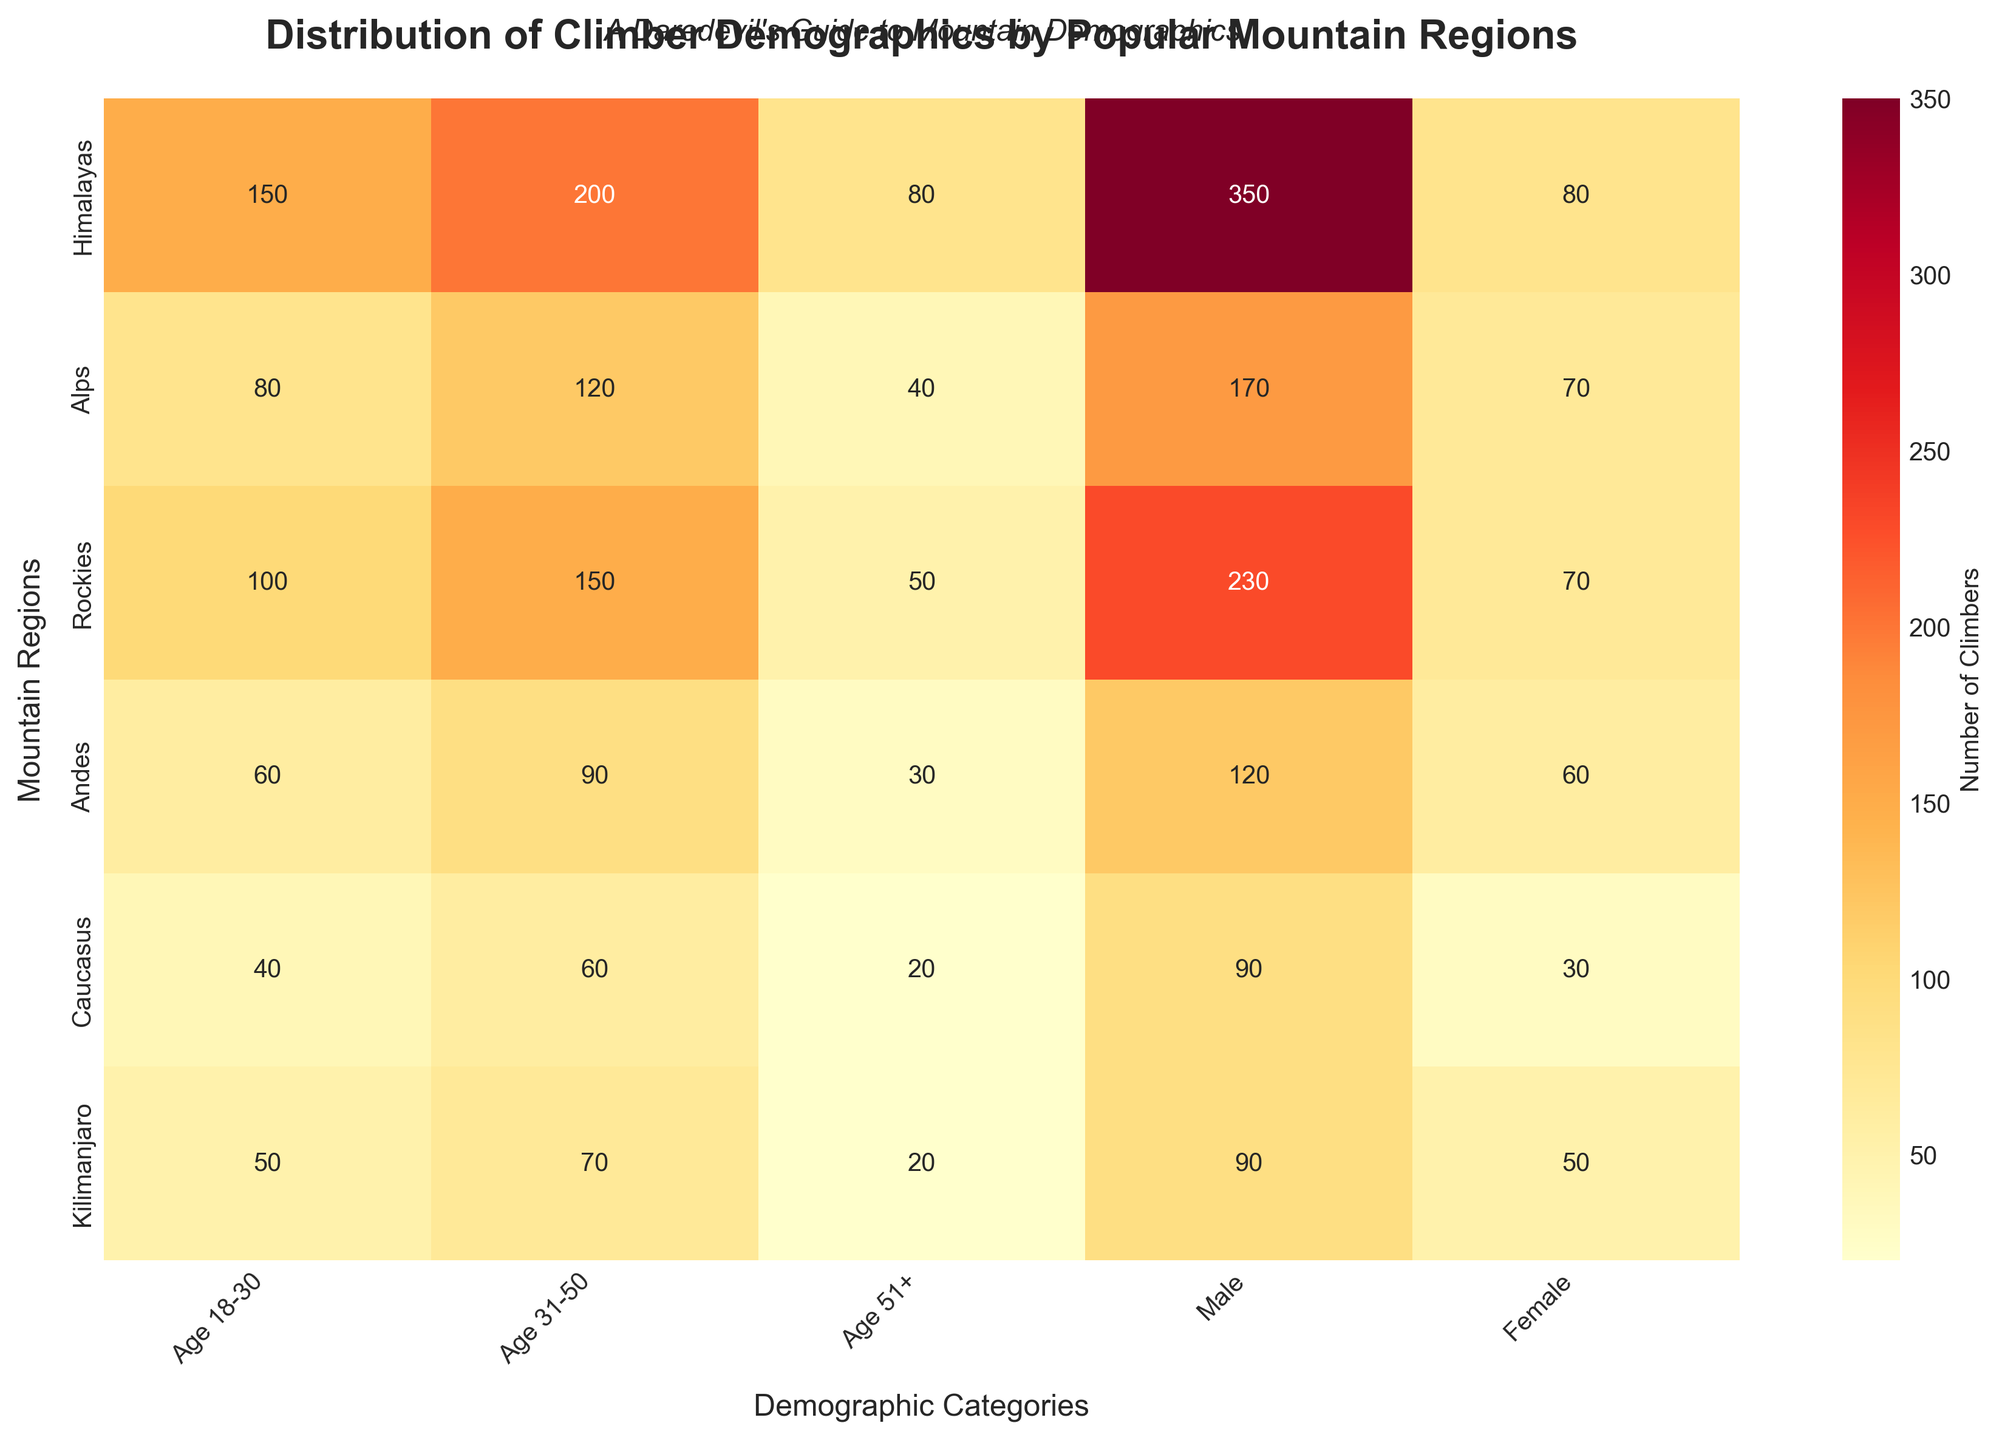What's the title of the heatmap? The title is written at the top center of the figure. It reads "Distribution of Climber Demographics by Popular Mountain Regions."
Answer: Distribution of Climber Demographics by Popular Mountain Regions Which region has the highest number of climbers aged 31-50? Look at the column "Age 31-50" and identify the highest value, which is in the Himalayas region (200).
Answer: Himalayas How many female climbers are there in the Rockies region? Follow the row labeled "Rockies" and then find the value in the "Female" column. The number is 70.
Answer: 70 What is the total number of climbers in the Alps region? Add all the demographic numbers in the Alps row (80 + 120 + 40 + 170 + 70 = 480).
Answer: 480 Which region has more climbers aged 18-30, the Andes or the Kilimanjaro? Compare the values in the "Age 18-30" column for Andes (60) and Kilimanjaro (50). The Andes has more climbers in this age group.
Answer: Andes What region has the lowest number of male climbers, and how many are there? Look at the "Male" column and identify the lowest value, which is in the Caucasus (90).
Answer: Caucasus, 90 What is the difference in the number of female climbers between the Himalayas and the Alps? Subtract the number of female climbers in the Alps (70) from the number in the Himalayas (80): 80 - 70 = 10.
Answer: 10 Calculate the average number of climbers aged 51+ across all regions. Add up the numbers in the "Age 51+" column (80 + 40 + 50 + 30 + 20 + 20 = 240) and divide by the number of regions (6): 240 / 6 = 40.
Answer: 40 Which region has the maximum diversity in terms of age demographics? Look for the region with the highest total sum in the age categories (18-30, 31-50, 51+). Himalayas (150 + 200 + 80 = 430) is the highest.
Answer: Himalayas 